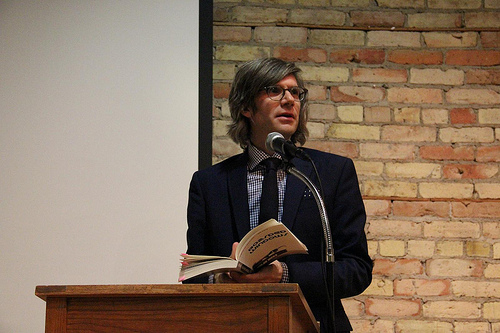<image>
Is there a man to the left of the book? No. The man is not to the left of the book. From this viewpoint, they have a different horizontal relationship. 